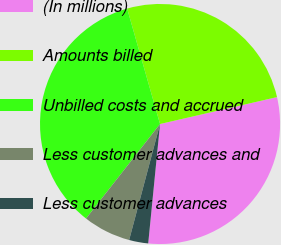Convert chart. <chart><loc_0><loc_0><loc_500><loc_500><pie_chart><fcel>(In millions)<fcel>Amounts billed<fcel>Unbilled costs and accrued<fcel>Less customer advances and<fcel>Less customer advances<nl><fcel>30.17%<fcel>25.82%<fcel>35.01%<fcel>6.43%<fcel>2.57%<nl></chart> 